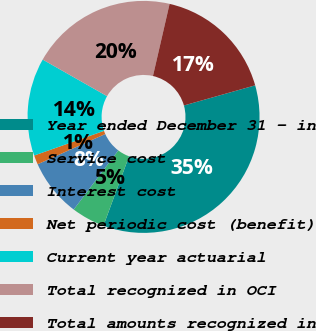Convert chart. <chart><loc_0><loc_0><loc_500><loc_500><pie_chart><fcel>Year ended December 31 - in<fcel>Service cost<fcel>Interest cost<fcel>Net periodic cost (benefit)<fcel>Current year actuarial<fcel>Total recognized in OCI<fcel>Total amounts recognized in<nl><fcel>35.01%<fcel>4.66%<fcel>8.03%<fcel>1.29%<fcel>13.63%<fcel>20.38%<fcel>17.01%<nl></chart> 